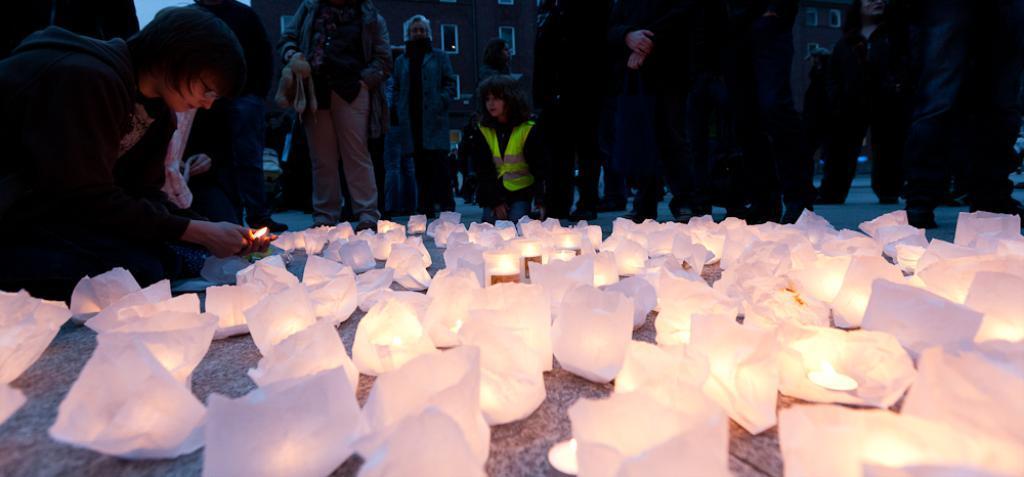Can you describe this image briefly? In this image, we can see persons wearing clothes. There are sky lanterns on the ground. In the background, we can see buildings. 